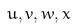Convert formula to latex. <formula><loc_0><loc_0><loc_500><loc_500>u , v , w , x</formula> 